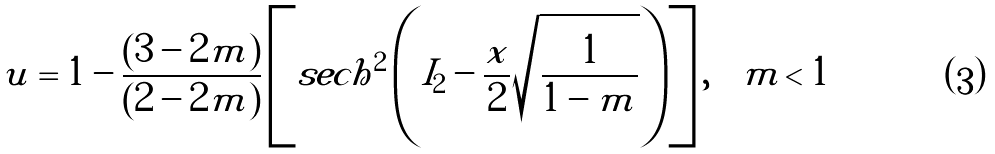Convert formula to latex. <formula><loc_0><loc_0><loc_500><loc_500>u = 1 - \frac { ( 3 - 2 m ) } { ( 2 - 2 m ) } \left [ s e c h ^ { 2 } \left ( I _ { 2 } - \frac { x } { 2 } \sqrt { \frac { 1 } { 1 - m } } \right ) \right ] , \quad m < 1</formula> 